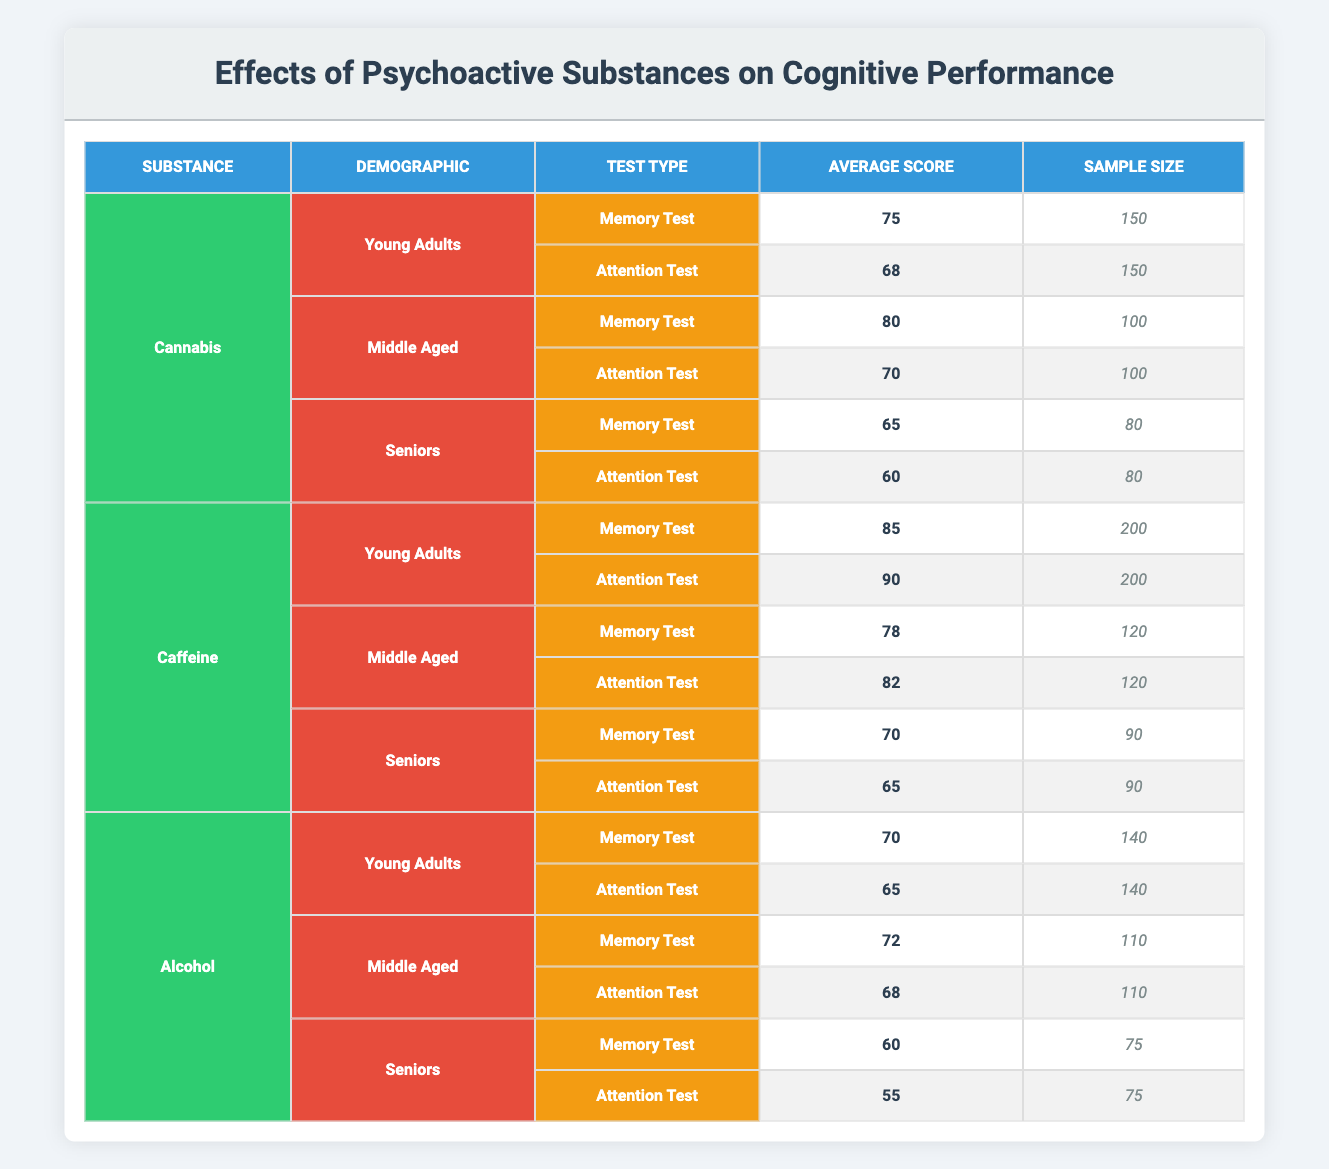What is the average score for the Memory Test among Young Adults using Cannabis? The average score for the Memory Test among Young Adults using Cannabis is 75, which is directly stated in the table under the Young Adults demographic.
Answer: 75 What is the sample size for the Attention Test given to Seniors consuming Caffeine? The sample size for the Attention Test for Seniors consuming Caffeine is 90, which can be found in the table under the Seniors demographic.
Answer: 90 Is the average Attention Test score for Middle-Aged individuals using Alcohol higher than that of Young Adults using Cannabis? According to the table, the average Attention Test score for Middle-Aged individuals using Alcohol is 68, while for Young Adults using Cannabis, it is 68 as well. Since both scores are equal, the answer is no.
Answer: No What is the difference in average Memory Test scores between the Young Adults using Caffeine and Seniors using Alcohol? The average Memory Test score for Young Adults using Caffeine is 85, while for Seniors using Alcohol it is 60. The difference is 85 - 60 = 25.
Answer: 25 What substance shows the lowest average score in the Attention Test for Seniors? From the table, the average Attention Test score for Seniors consuming Alcohol is 55, which is the lowest compared to the scores of Seniors consuming Cannabis (60) and Caffeine (65).
Answer: Alcohol What is the average Memory Test score across all demographics for Caffeine? The average Memory Test scores for Caffeine are: 85 for Young Adults, 78 for Middle-Aged, and 70 for Seniors. To find the average, sum them: 85 + 78 + 70 = 233 and divide by the number of groups (3). The average is 233 / 3 = approximately 77.67.
Answer: 77.67 Does Cannabis have a better effect on cognitive performance in terms of Memory Test scores compared to Alcohol among Middle-Aged individuals? For Middle-Aged individuals, Cannabis has an average Memory Test score of 80, while Alcohol has a score of 72. Since 80 is greater than 72, the answer is yes.
Answer: Yes What substance has the highest average Attention Test score among Young Adults? In the table, Young Adults using Caffeine have the highest average Attention Test score of 90, compared to 68 for Cannabis and 65 for Alcohol.
Answer: Caffeine 